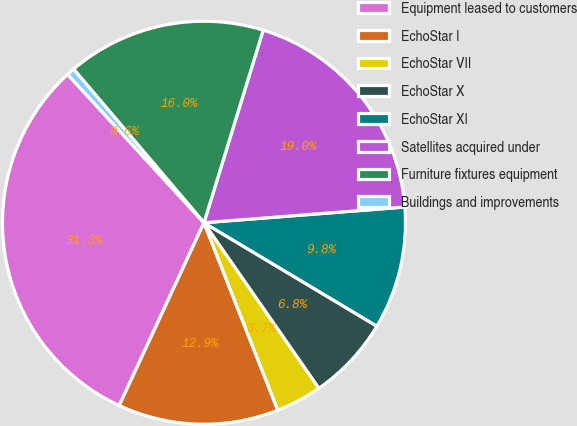Convert chart to OTSL. <chart><loc_0><loc_0><loc_500><loc_500><pie_chart><fcel>Equipment leased to customers<fcel>EchoStar I<fcel>EchoStar VII<fcel>EchoStar X<fcel>EchoStar XI<fcel>Satellites acquired under<fcel>Furniture fixtures equipment<fcel>Buildings and improvements<nl><fcel>31.26%<fcel>12.88%<fcel>3.69%<fcel>6.76%<fcel>9.82%<fcel>19.01%<fcel>15.95%<fcel>0.63%<nl></chart> 